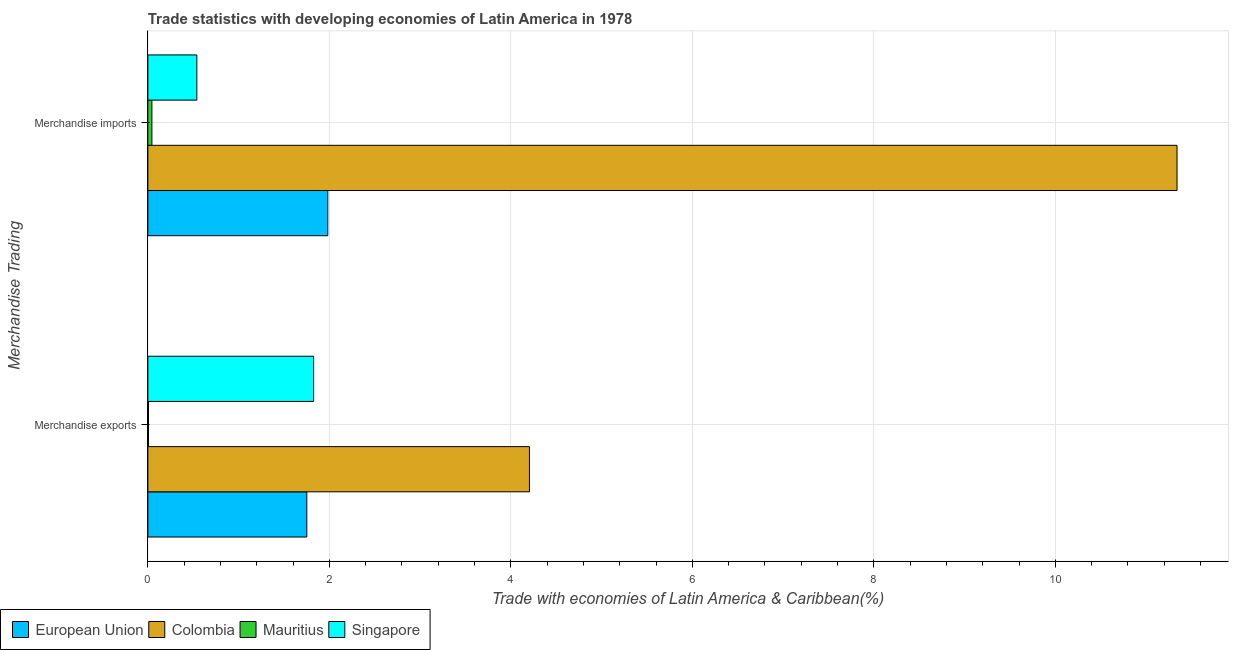How many groups of bars are there?
Provide a succinct answer. 2. Are the number of bars per tick equal to the number of legend labels?
Your response must be concise. Yes. Are the number of bars on each tick of the Y-axis equal?
Offer a terse response. Yes. What is the merchandise exports in Mauritius?
Offer a terse response. 0.01. Across all countries, what is the maximum merchandise exports?
Keep it short and to the point. 4.2. Across all countries, what is the minimum merchandise exports?
Make the answer very short. 0.01. In which country was the merchandise imports minimum?
Your answer should be very brief. Mauritius. What is the total merchandise imports in the graph?
Offer a terse response. 13.91. What is the difference between the merchandise exports in European Union and that in Singapore?
Ensure brevity in your answer.  -0.08. What is the difference between the merchandise exports in Singapore and the merchandise imports in European Union?
Provide a short and direct response. -0.16. What is the average merchandise imports per country?
Give a very brief answer. 3.48. What is the difference between the merchandise imports and merchandise exports in Mauritius?
Provide a short and direct response. 0.04. What is the ratio of the merchandise exports in Mauritius to that in Singapore?
Provide a succinct answer. 0. Is the merchandise exports in Singapore less than that in Mauritius?
Provide a succinct answer. No. What does the 1st bar from the bottom in Merchandise exports represents?
Offer a very short reply. European Union. How many bars are there?
Provide a short and direct response. 8. Are all the bars in the graph horizontal?
Give a very brief answer. Yes. How many countries are there in the graph?
Your answer should be very brief. 4. What is the title of the graph?
Offer a very short reply. Trade statistics with developing economies of Latin America in 1978. Does "Senegal" appear as one of the legend labels in the graph?
Offer a very short reply. No. What is the label or title of the X-axis?
Make the answer very short. Trade with economies of Latin America & Caribbean(%). What is the label or title of the Y-axis?
Provide a succinct answer. Merchandise Trading. What is the Trade with economies of Latin America & Caribbean(%) in European Union in Merchandise exports?
Offer a very short reply. 1.75. What is the Trade with economies of Latin America & Caribbean(%) of Colombia in Merchandise exports?
Your answer should be very brief. 4.2. What is the Trade with economies of Latin America & Caribbean(%) of Mauritius in Merchandise exports?
Your response must be concise. 0.01. What is the Trade with economies of Latin America & Caribbean(%) in Singapore in Merchandise exports?
Ensure brevity in your answer.  1.83. What is the Trade with economies of Latin America & Caribbean(%) of European Union in Merchandise imports?
Make the answer very short. 1.98. What is the Trade with economies of Latin America & Caribbean(%) of Colombia in Merchandise imports?
Give a very brief answer. 11.34. What is the Trade with economies of Latin America & Caribbean(%) in Mauritius in Merchandise imports?
Give a very brief answer. 0.04. What is the Trade with economies of Latin America & Caribbean(%) of Singapore in Merchandise imports?
Ensure brevity in your answer.  0.54. Across all Merchandise Trading, what is the maximum Trade with economies of Latin America & Caribbean(%) in European Union?
Your answer should be compact. 1.98. Across all Merchandise Trading, what is the maximum Trade with economies of Latin America & Caribbean(%) in Colombia?
Your answer should be compact. 11.34. Across all Merchandise Trading, what is the maximum Trade with economies of Latin America & Caribbean(%) in Mauritius?
Keep it short and to the point. 0.04. Across all Merchandise Trading, what is the maximum Trade with economies of Latin America & Caribbean(%) in Singapore?
Give a very brief answer. 1.83. Across all Merchandise Trading, what is the minimum Trade with economies of Latin America & Caribbean(%) of European Union?
Make the answer very short. 1.75. Across all Merchandise Trading, what is the minimum Trade with economies of Latin America & Caribbean(%) of Colombia?
Offer a very short reply. 4.2. Across all Merchandise Trading, what is the minimum Trade with economies of Latin America & Caribbean(%) in Mauritius?
Your response must be concise. 0.01. Across all Merchandise Trading, what is the minimum Trade with economies of Latin America & Caribbean(%) in Singapore?
Give a very brief answer. 0.54. What is the total Trade with economies of Latin America & Caribbean(%) in European Union in the graph?
Provide a short and direct response. 3.73. What is the total Trade with economies of Latin America & Caribbean(%) of Colombia in the graph?
Your answer should be very brief. 15.55. What is the total Trade with economies of Latin America & Caribbean(%) of Mauritius in the graph?
Offer a terse response. 0.05. What is the total Trade with economies of Latin America & Caribbean(%) of Singapore in the graph?
Offer a very short reply. 2.37. What is the difference between the Trade with economies of Latin America & Caribbean(%) of European Union in Merchandise exports and that in Merchandise imports?
Give a very brief answer. -0.23. What is the difference between the Trade with economies of Latin America & Caribbean(%) in Colombia in Merchandise exports and that in Merchandise imports?
Your answer should be compact. -7.14. What is the difference between the Trade with economies of Latin America & Caribbean(%) in Mauritius in Merchandise exports and that in Merchandise imports?
Your response must be concise. -0.04. What is the difference between the Trade with economies of Latin America & Caribbean(%) of Singapore in Merchandise exports and that in Merchandise imports?
Make the answer very short. 1.29. What is the difference between the Trade with economies of Latin America & Caribbean(%) in European Union in Merchandise exports and the Trade with economies of Latin America & Caribbean(%) in Colombia in Merchandise imports?
Ensure brevity in your answer.  -9.59. What is the difference between the Trade with economies of Latin America & Caribbean(%) in European Union in Merchandise exports and the Trade with economies of Latin America & Caribbean(%) in Mauritius in Merchandise imports?
Provide a short and direct response. 1.71. What is the difference between the Trade with economies of Latin America & Caribbean(%) in European Union in Merchandise exports and the Trade with economies of Latin America & Caribbean(%) in Singapore in Merchandise imports?
Provide a succinct answer. 1.21. What is the difference between the Trade with economies of Latin America & Caribbean(%) of Colombia in Merchandise exports and the Trade with economies of Latin America & Caribbean(%) of Mauritius in Merchandise imports?
Make the answer very short. 4.16. What is the difference between the Trade with economies of Latin America & Caribbean(%) of Colombia in Merchandise exports and the Trade with economies of Latin America & Caribbean(%) of Singapore in Merchandise imports?
Provide a short and direct response. 3.67. What is the difference between the Trade with economies of Latin America & Caribbean(%) in Mauritius in Merchandise exports and the Trade with economies of Latin America & Caribbean(%) in Singapore in Merchandise imports?
Offer a terse response. -0.53. What is the average Trade with economies of Latin America & Caribbean(%) of European Union per Merchandise Trading?
Offer a terse response. 1.87. What is the average Trade with economies of Latin America & Caribbean(%) in Colombia per Merchandise Trading?
Offer a terse response. 7.77. What is the average Trade with economies of Latin America & Caribbean(%) of Mauritius per Merchandise Trading?
Give a very brief answer. 0.03. What is the average Trade with economies of Latin America & Caribbean(%) of Singapore per Merchandise Trading?
Ensure brevity in your answer.  1.18. What is the difference between the Trade with economies of Latin America & Caribbean(%) of European Union and Trade with economies of Latin America & Caribbean(%) of Colombia in Merchandise exports?
Provide a succinct answer. -2.45. What is the difference between the Trade with economies of Latin America & Caribbean(%) in European Union and Trade with economies of Latin America & Caribbean(%) in Mauritius in Merchandise exports?
Ensure brevity in your answer.  1.74. What is the difference between the Trade with economies of Latin America & Caribbean(%) of European Union and Trade with economies of Latin America & Caribbean(%) of Singapore in Merchandise exports?
Give a very brief answer. -0.08. What is the difference between the Trade with economies of Latin America & Caribbean(%) of Colombia and Trade with economies of Latin America & Caribbean(%) of Mauritius in Merchandise exports?
Offer a very short reply. 4.2. What is the difference between the Trade with economies of Latin America & Caribbean(%) of Colombia and Trade with economies of Latin America & Caribbean(%) of Singapore in Merchandise exports?
Keep it short and to the point. 2.38. What is the difference between the Trade with economies of Latin America & Caribbean(%) in Mauritius and Trade with economies of Latin America & Caribbean(%) in Singapore in Merchandise exports?
Your response must be concise. -1.82. What is the difference between the Trade with economies of Latin America & Caribbean(%) in European Union and Trade with economies of Latin America & Caribbean(%) in Colombia in Merchandise imports?
Give a very brief answer. -9.36. What is the difference between the Trade with economies of Latin America & Caribbean(%) of European Union and Trade with economies of Latin America & Caribbean(%) of Mauritius in Merchandise imports?
Provide a short and direct response. 1.94. What is the difference between the Trade with economies of Latin America & Caribbean(%) of European Union and Trade with economies of Latin America & Caribbean(%) of Singapore in Merchandise imports?
Ensure brevity in your answer.  1.44. What is the difference between the Trade with economies of Latin America & Caribbean(%) in Colombia and Trade with economies of Latin America & Caribbean(%) in Mauritius in Merchandise imports?
Offer a very short reply. 11.3. What is the difference between the Trade with economies of Latin America & Caribbean(%) in Colombia and Trade with economies of Latin America & Caribbean(%) in Singapore in Merchandise imports?
Make the answer very short. 10.8. What is the difference between the Trade with economies of Latin America & Caribbean(%) of Mauritius and Trade with economies of Latin America & Caribbean(%) of Singapore in Merchandise imports?
Give a very brief answer. -0.5. What is the ratio of the Trade with economies of Latin America & Caribbean(%) of European Union in Merchandise exports to that in Merchandise imports?
Offer a very short reply. 0.88. What is the ratio of the Trade with economies of Latin America & Caribbean(%) in Colombia in Merchandise exports to that in Merchandise imports?
Offer a very short reply. 0.37. What is the ratio of the Trade with economies of Latin America & Caribbean(%) of Mauritius in Merchandise exports to that in Merchandise imports?
Your response must be concise. 0.16. What is the ratio of the Trade with economies of Latin America & Caribbean(%) in Singapore in Merchandise exports to that in Merchandise imports?
Give a very brief answer. 3.39. What is the difference between the highest and the second highest Trade with economies of Latin America & Caribbean(%) of European Union?
Your response must be concise. 0.23. What is the difference between the highest and the second highest Trade with economies of Latin America & Caribbean(%) in Colombia?
Provide a succinct answer. 7.14. What is the difference between the highest and the second highest Trade with economies of Latin America & Caribbean(%) of Mauritius?
Ensure brevity in your answer.  0.04. What is the difference between the highest and the second highest Trade with economies of Latin America & Caribbean(%) in Singapore?
Your answer should be very brief. 1.29. What is the difference between the highest and the lowest Trade with economies of Latin America & Caribbean(%) of European Union?
Ensure brevity in your answer.  0.23. What is the difference between the highest and the lowest Trade with economies of Latin America & Caribbean(%) of Colombia?
Ensure brevity in your answer.  7.14. What is the difference between the highest and the lowest Trade with economies of Latin America & Caribbean(%) in Mauritius?
Your answer should be compact. 0.04. What is the difference between the highest and the lowest Trade with economies of Latin America & Caribbean(%) of Singapore?
Provide a short and direct response. 1.29. 